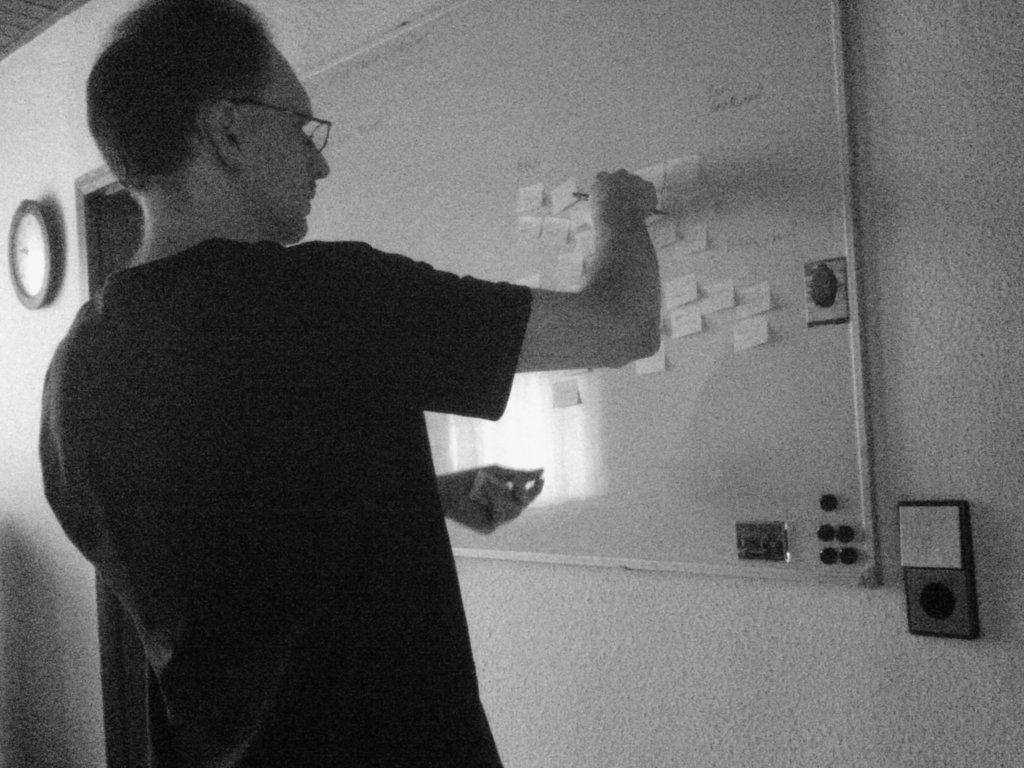Who is the person in the image? There is a man in the image. What is the man doing in the image? The man is standing in front of a board and sticking notes to it. What can be seen on the wall in the image? There is a clock on the wall on the left side of the image. Can you tell me how many lands are visible in the image? There are no lands visible in the image; it features a man standing in front of a board with notes and a clock on the wall. What type of idea is the man trying to convey with the notes on the board? The image does not provide information about the content or meaning of the notes on the board, so it is impossible to determine the idea being conveyed. 